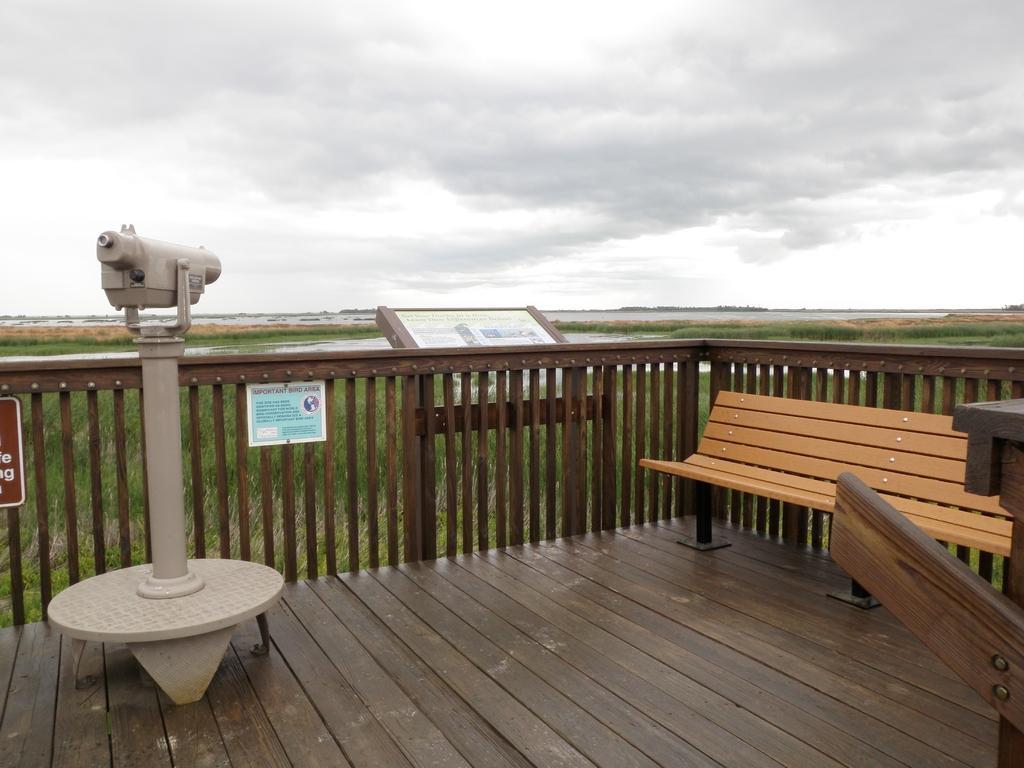How would you summarize this image in a sentence or two? In this image I can see the wooden floor which is brown in color, a bench, the railing, few boards, a cream colored object to the pole and some grass. In the background I can see the water and the sky. 